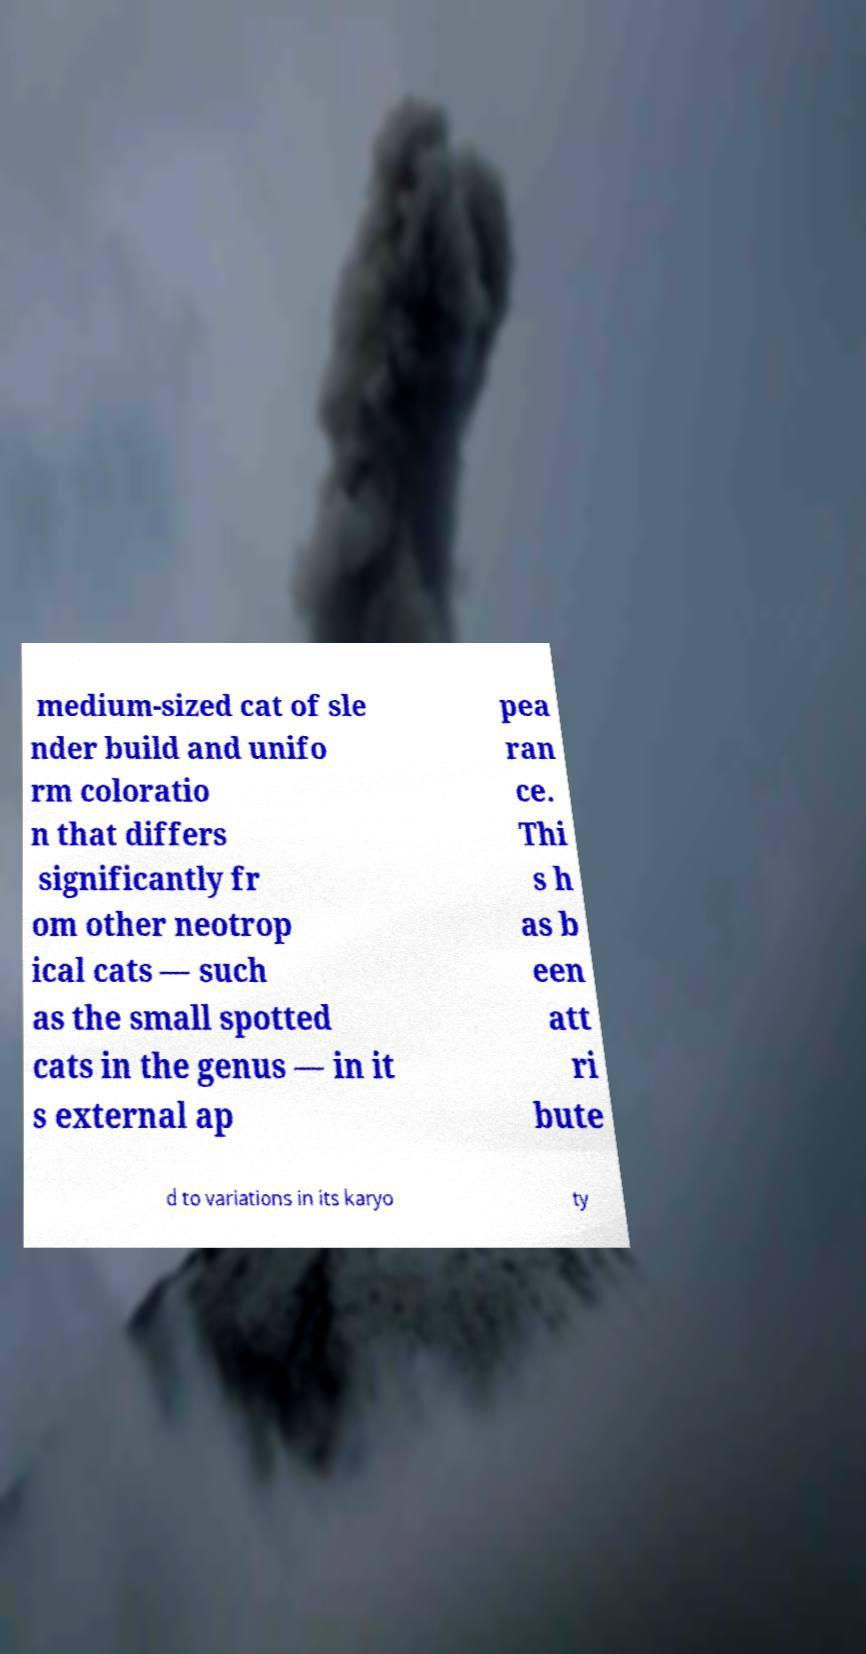There's text embedded in this image that I need extracted. Can you transcribe it verbatim? medium-sized cat of sle nder build and unifo rm coloratio n that differs significantly fr om other neotrop ical cats — such as the small spotted cats in the genus — in it s external ap pea ran ce. Thi s h as b een att ri bute d to variations in its karyo ty 